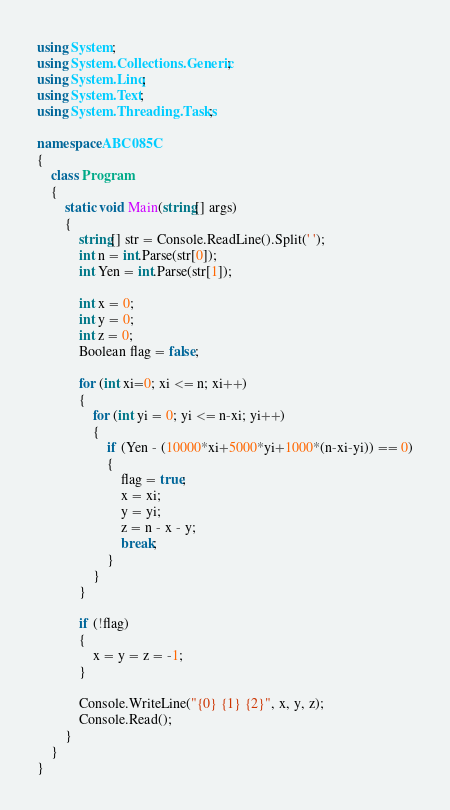Convert code to text. <code><loc_0><loc_0><loc_500><loc_500><_C#_>using System;
using System.Collections.Generic;
using System.Linq;
using System.Text;
using System.Threading.Tasks;

namespace ABC085C
{
    class Program
    {
        static void Main(string[] args)
        {
            string[] str = Console.ReadLine().Split(' ');
            int n = int.Parse(str[0]);
            int Yen = int.Parse(str[1]);

            int x = 0;
            int y = 0;
            int z = 0;
            Boolean flag = false;

            for (int xi=0; xi <= n; xi++)
            {
                for (int yi = 0; yi <= n-xi; yi++)
                {
                    if (Yen - (10000*xi+5000*yi+1000*(n-xi-yi)) == 0)
                    {
                        flag = true;
                        x = xi;
                        y = yi;
                        z = n - x - y;
                        break;
                    }
                }
            }

            if (!flag)
            {
                x = y = z = -1;
            }

            Console.WriteLine("{0} {1} {2}", x, y, z);
            Console.Read();
        }
    }
}
</code> 